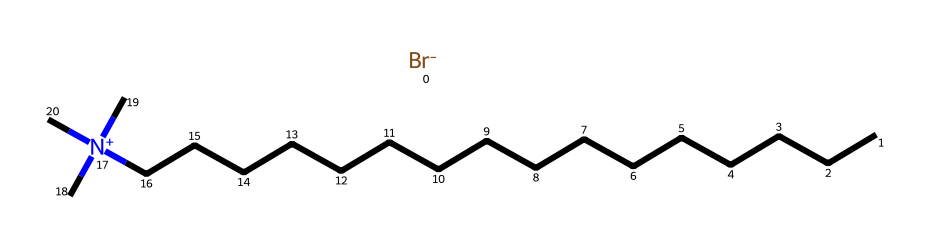What is the total number of carbon atoms in cetrimonium bromide? The SMILES representation shows a linear chain of carbon atoms denoted by 'C'. Counting the 'CCCCCCCCCCCCCCCC' part indicates there are 16 carbon atoms in total.
Answer: 16 What functional group is present in cetrimonium bromide? The presence of the '[N+](C)(C)C' in the SMILES indicates a quaternary ammonium functional group, characterized by the positively charged nitrogen atom linked to three carbon groups.
Answer: quaternary ammonium How many nitrogen atoms are in cetrimonium bromide? Observing the structure, there is a single '[N+]' notation, which signifies one nitrogen atom present in the chemical.
Answer: 1 Is cetrimonium bromide ionic or covalent? The presence of the '[Br-]' indicates that there is an ionic bond with the bromide ion, while the carbon chains and quaternary ammonium structure suggest that parts of it are covalently bonded. Given the presence of these contrasting features, cetrimonium bromide is classified as an ionic compound due to the ionic interaction with bromine.
Answer: ionic What role does cetrimonium bromide play in antimicrobial sprays? Cetrimonium bromide acts as a surfactant that disrupts microbial cell membranes, leading to its effectiveness as an antimicrobial agent. This is typical for quaternary ammonium compounds, which are known for their antimicrobial properties.
Answer: antimicrobial agent How does the length of the carbon chain in cetrimonium bromide influence its properties? Longer carbon chains generally enhance the surfactant properties by increasing surface activity and stability in formulations, which is evident in cetrimonium bromide’s hydrophobic character. This contributes to its effectiveness as a surfactant, especially in cleaning and antimicrobial applications.
Answer: enhances surfactant properties 